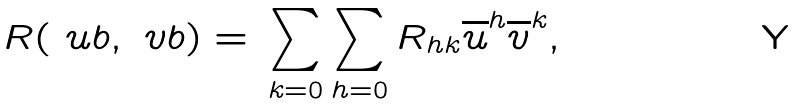Convert formula to latex. <formula><loc_0><loc_0><loc_500><loc_500>R ( \ u b , \ v b ) = \, \sum _ { k = 0 } \sum _ { h = 0 } R _ { h k } \overline { u } ^ { h } \overline { v } ^ { k } ,</formula> 